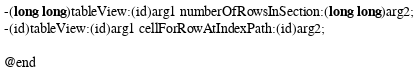Convert code to text. <code><loc_0><loc_0><loc_500><loc_500><_C_>-(long long)tableView:(id)arg1 numberOfRowsInSection:(long long)arg2;
-(id)tableView:(id)arg1 cellForRowAtIndexPath:(id)arg2;

@end

</code> 